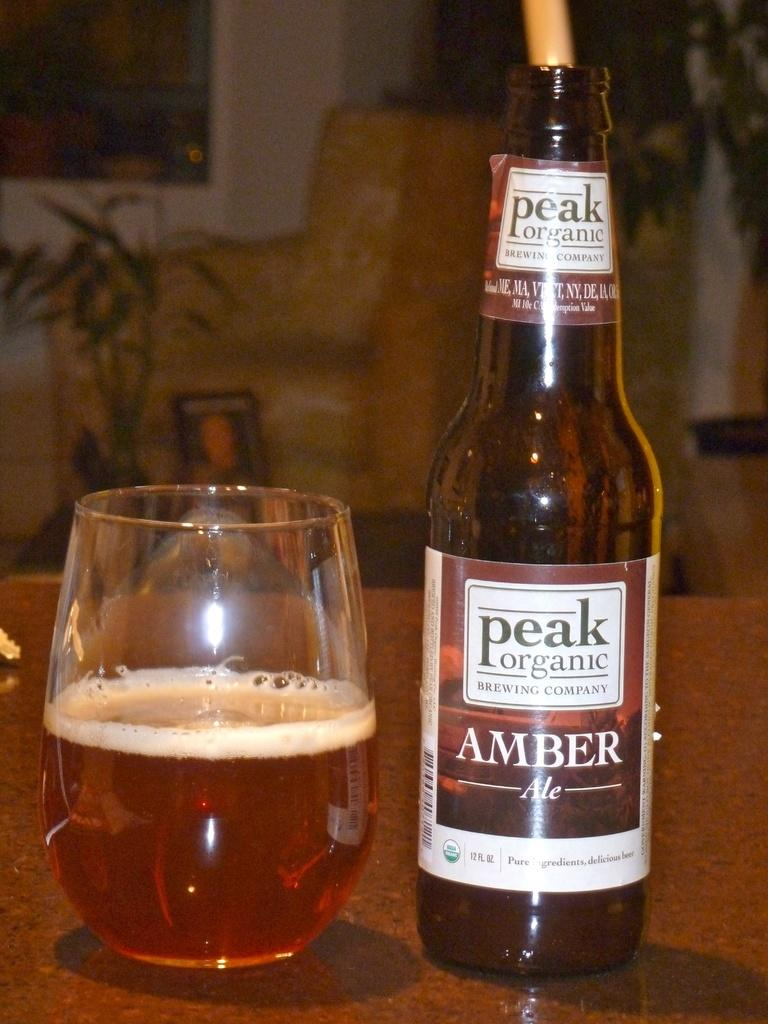<image>
Relay a brief, clear account of the picture shown. A bottle of amber ale is on a table by a half filled glass. 